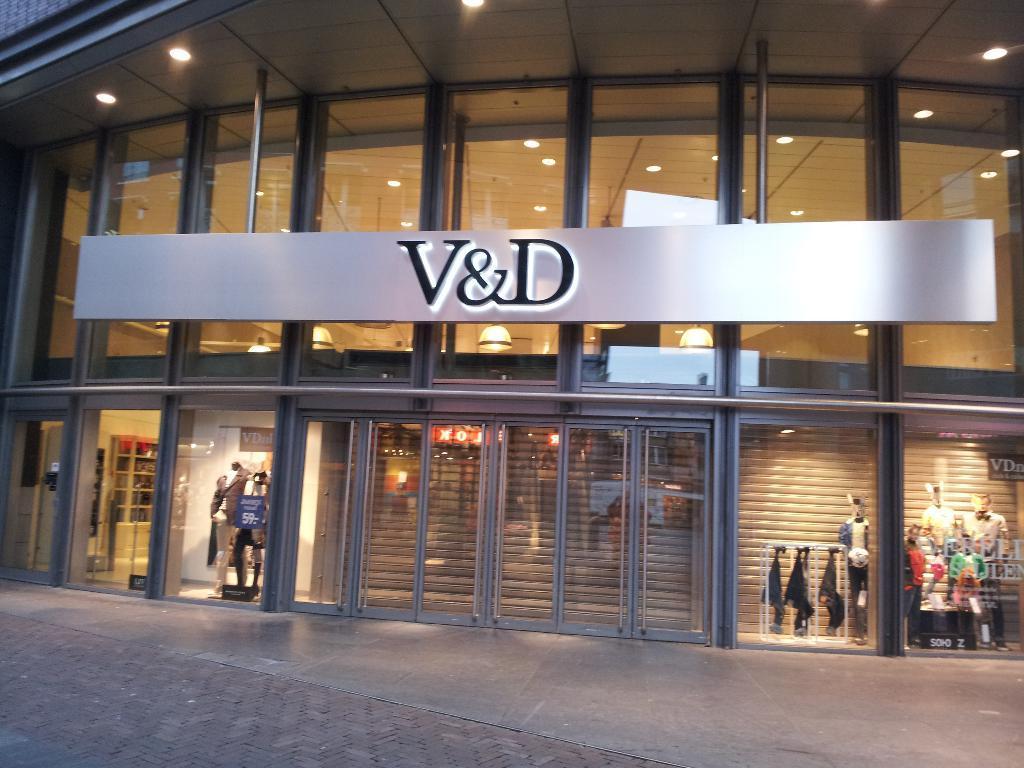Please provide a concise description of this image. In this image I can see mannequins on the floor, clothes are hanged, lights, board, doors, glass, pipe and a building. This image is taken may be during night. 